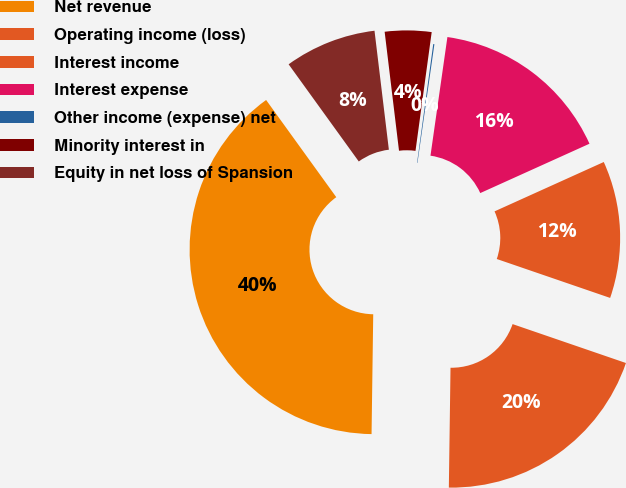<chart> <loc_0><loc_0><loc_500><loc_500><pie_chart><fcel>Net revenue<fcel>Operating income (loss)<fcel>Interest income<fcel>Interest expense<fcel>Other income (expense) net<fcel>Minority interest in<fcel>Equity in net loss of Spansion<nl><fcel>39.83%<fcel>19.96%<fcel>12.02%<fcel>15.99%<fcel>0.1%<fcel>4.07%<fcel>8.04%<nl></chart> 